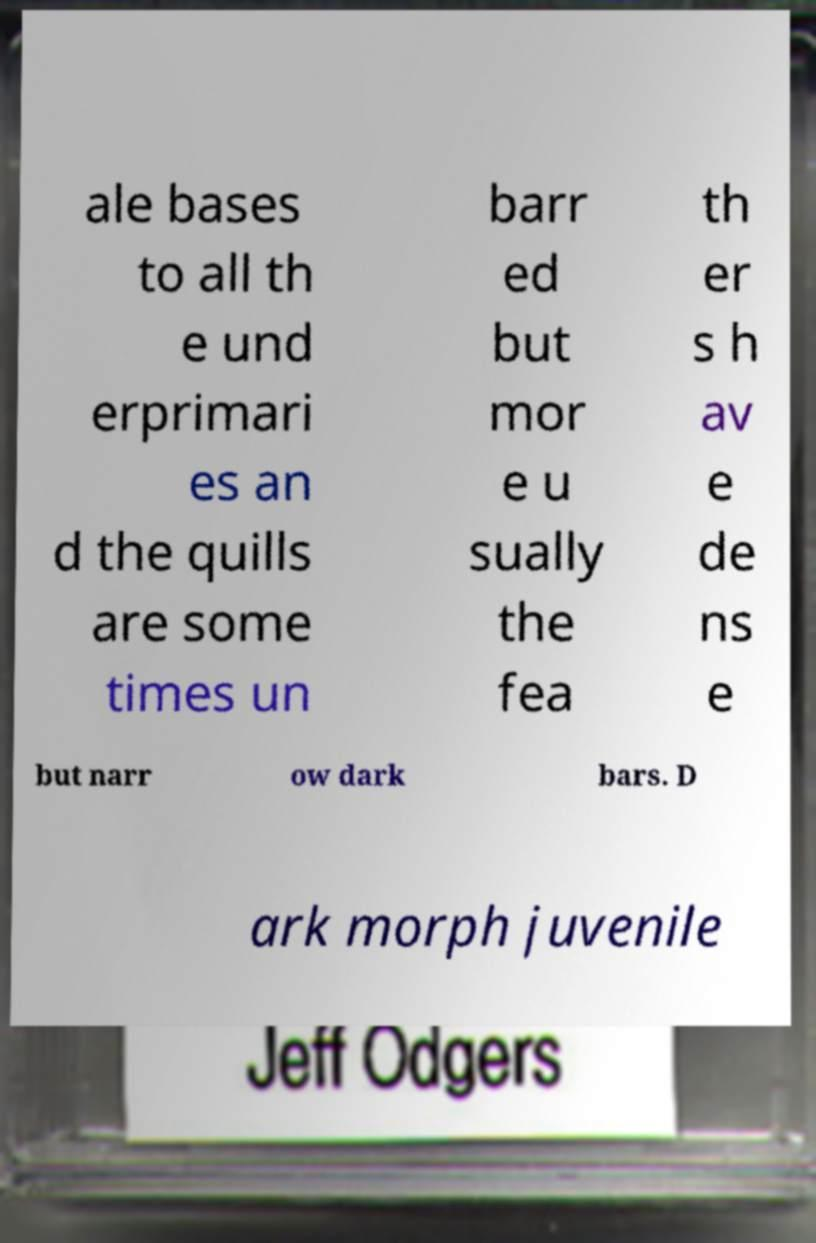For documentation purposes, I need the text within this image transcribed. Could you provide that? ale bases to all th e und erprimari es an d the quills are some times un barr ed but mor e u sually the fea th er s h av e de ns e but narr ow dark bars. D ark morph juvenile 